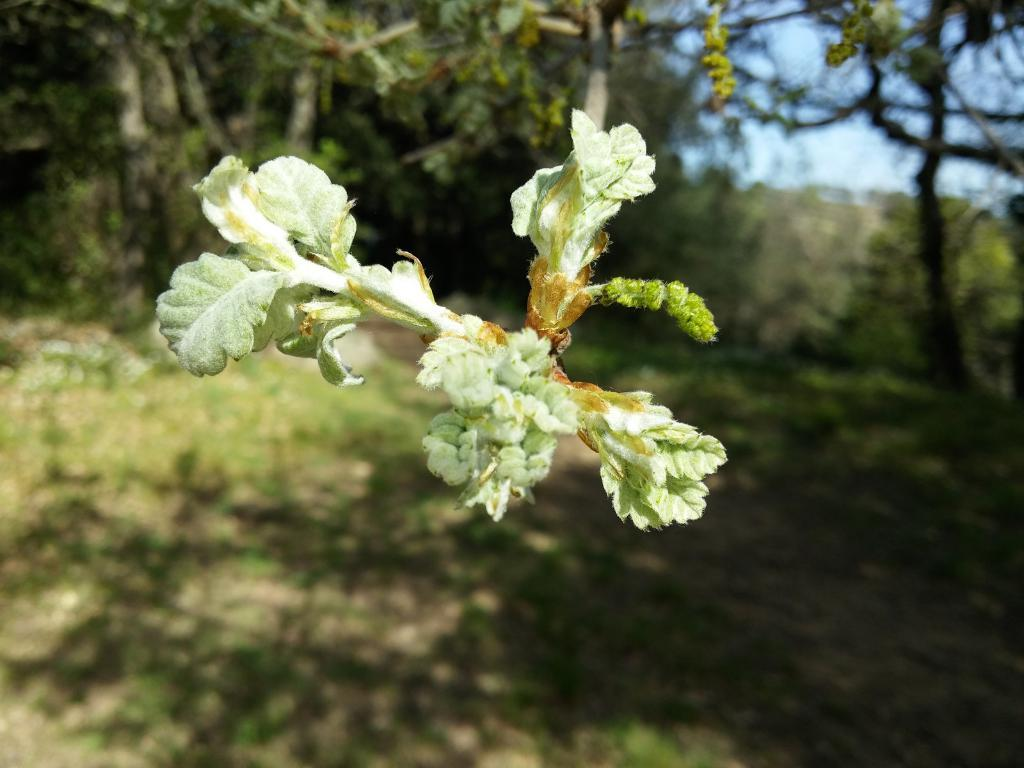What type of vegetation can be seen on the tree in the image? There are flowers on the tree in the image. What else can be seen in the background of the image? There are trees visible in the background of the image. What is visible at the top of the image? The sky is visible at the top of the image. What type of ground cover is present at the bottom of the image? There is grass at the bottom of the image. What is the result of the tree's presence in the image? There is a shadow of the tree on the grass. Can you see any magic happening in the image? There is no magic present in the image. How many ladybugs are visible on the tree in the image? There are no ladybugs visible on the tree in the image. 